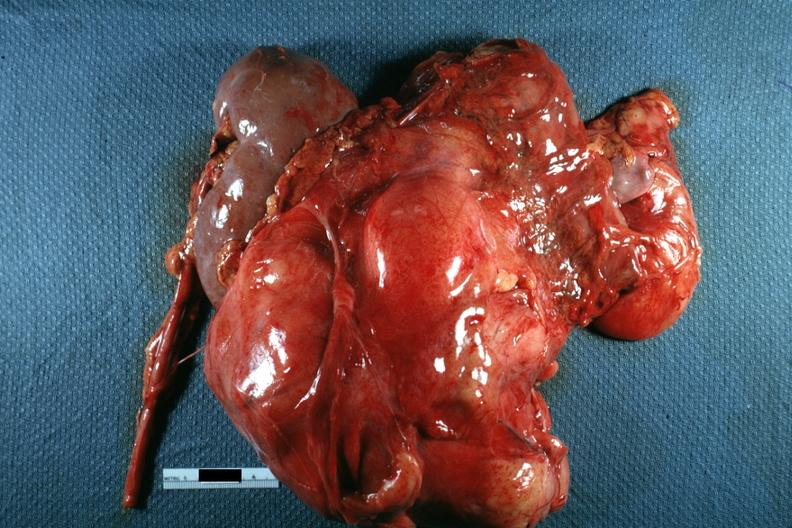what is present?
Answer the question using a single word or phrase. Peritoneum 